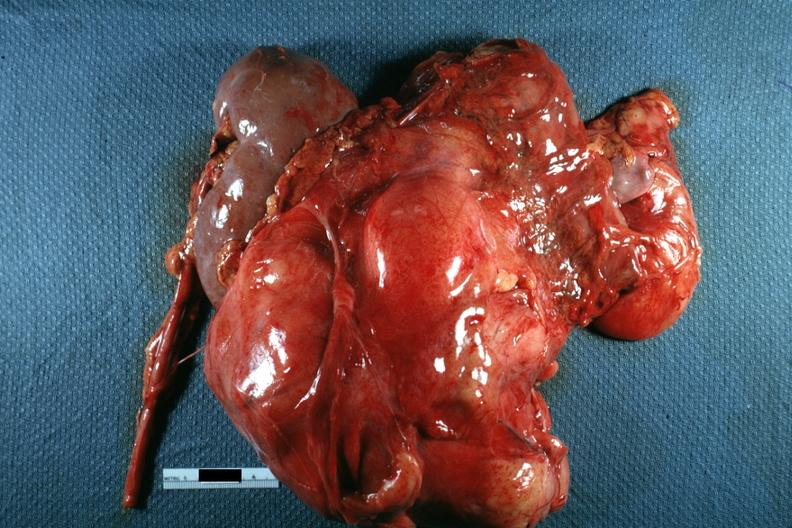what is present?
Answer the question using a single word or phrase. Peritoneum 